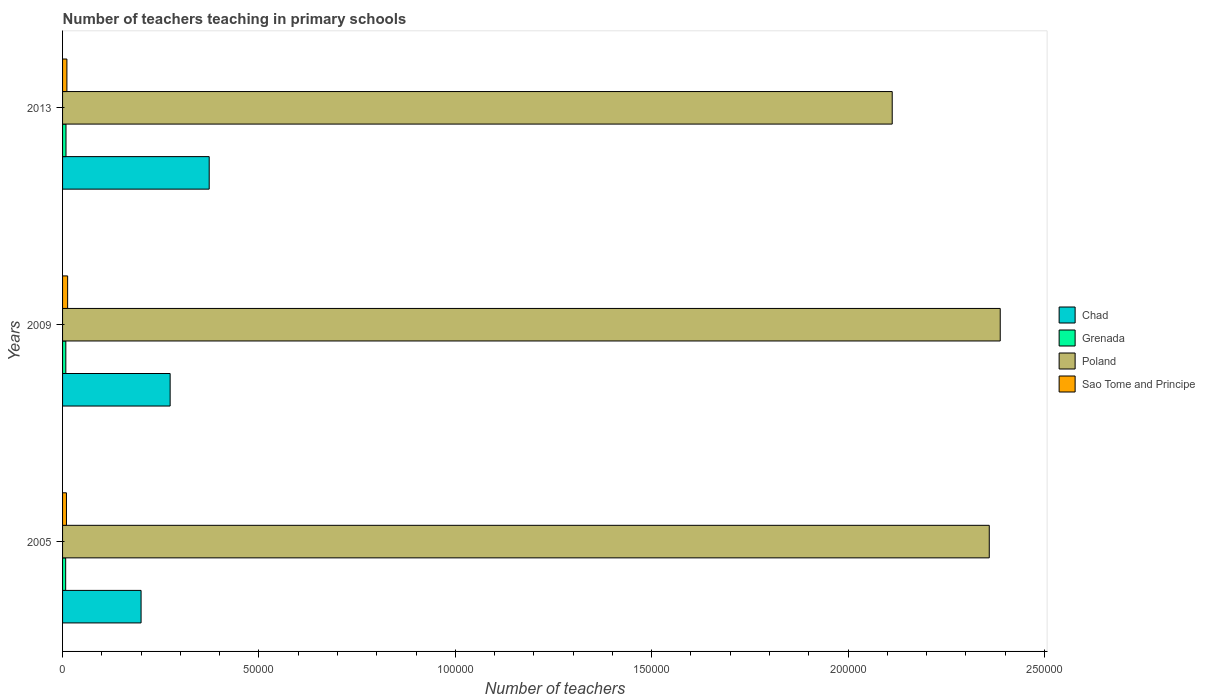How many bars are there on the 2nd tick from the top?
Your answer should be very brief. 4. How many bars are there on the 3rd tick from the bottom?
Make the answer very short. 4. What is the label of the 3rd group of bars from the top?
Your answer should be very brief. 2005. What is the number of teachers teaching in primary schools in Sao Tome and Principe in 2013?
Provide a short and direct response. 1107. Across all years, what is the maximum number of teachers teaching in primary schools in Poland?
Your answer should be compact. 2.39e+05. Across all years, what is the minimum number of teachers teaching in primary schools in Poland?
Offer a terse response. 2.11e+05. In which year was the number of teachers teaching in primary schools in Grenada maximum?
Your response must be concise. 2013. In which year was the number of teachers teaching in primary schools in Chad minimum?
Your response must be concise. 2005. What is the total number of teachers teaching in primary schools in Grenada in the graph?
Offer a very short reply. 2496. What is the difference between the number of teachers teaching in primary schools in Sao Tome and Principe in 2009 and that in 2013?
Keep it short and to the point. 184. What is the difference between the number of teachers teaching in primary schools in Grenada in 2005 and the number of teachers teaching in primary schools in Chad in 2013?
Offer a very short reply. -3.65e+04. What is the average number of teachers teaching in primary schools in Sao Tome and Principe per year?
Your response must be concise. 1129.33. In the year 2005, what is the difference between the number of teachers teaching in primary schools in Sao Tome and Principe and number of teachers teaching in primary schools in Chad?
Give a very brief answer. -1.90e+04. In how many years, is the number of teachers teaching in primary schools in Grenada greater than 10000 ?
Give a very brief answer. 0. What is the ratio of the number of teachers teaching in primary schools in Poland in 2005 to that in 2009?
Offer a very short reply. 0.99. What is the difference between the highest and the lowest number of teachers teaching in primary schools in Sao Tome and Principe?
Offer a terse response. 301. In how many years, is the number of teachers teaching in primary schools in Chad greater than the average number of teachers teaching in primary schools in Chad taken over all years?
Your response must be concise. 1. Is it the case that in every year, the sum of the number of teachers teaching in primary schools in Poland and number of teachers teaching in primary schools in Sao Tome and Principe is greater than the sum of number of teachers teaching in primary schools in Grenada and number of teachers teaching in primary schools in Chad?
Offer a very short reply. Yes. What does the 3rd bar from the top in 2009 represents?
Ensure brevity in your answer.  Grenada. What does the 3rd bar from the bottom in 2013 represents?
Your answer should be compact. Poland. Is it the case that in every year, the sum of the number of teachers teaching in primary schools in Poland and number of teachers teaching in primary schools in Sao Tome and Principe is greater than the number of teachers teaching in primary schools in Chad?
Your answer should be compact. Yes. Are all the bars in the graph horizontal?
Offer a very short reply. Yes. How many years are there in the graph?
Your answer should be compact. 3. What is the difference between two consecutive major ticks on the X-axis?
Make the answer very short. 5.00e+04. Are the values on the major ticks of X-axis written in scientific E-notation?
Give a very brief answer. No. Does the graph contain any zero values?
Keep it short and to the point. No. Where does the legend appear in the graph?
Offer a terse response. Center right. How many legend labels are there?
Offer a very short reply. 4. What is the title of the graph?
Your response must be concise. Number of teachers teaching in primary schools. What is the label or title of the X-axis?
Make the answer very short. Number of teachers. What is the Number of teachers in Chad in 2005?
Keep it short and to the point. 2.00e+04. What is the Number of teachers in Grenada in 2005?
Your response must be concise. 791. What is the Number of teachers in Poland in 2005?
Ensure brevity in your answer.  2.36e+05. What is the Number of teachers of Sao Tome and Principe in 2005?
Make the answer very short. 990. What is the Number of teachers in Chad in 2009?
Provide a succinct answer. 2.74e+04. What is the Number of teachers in Grenada in 2009?
Your answer should be very brief. 830. What is the Number of teachers in Poland in 2009?
Offer a terse response. 2.39e+05. What is the Number of teachers in Sao Tome and Principe in 2009?
Ensure brevity in your answer.  1291. What is the Number of teachers of Chad in 2013?
Your response must be concise. 3.73e+04. What is the Number of teachers of Grenada in 2013?
Keep it short and to the point. 875. What is the Number of teachers in Poland in 2013?
Provide a succinct answer. 2.11e+05. What is the Number of teachers of Sao Tome and Principe in 2013?
Offer a terse response. 1107. Across all years, what is the maximum Number of teachers in Chad?
Ensure brevity in your answer.  3.73e+04. Across all years, what is the maximum Number of teachers of Grenada?
Ensure brevity in your answer.  875. Across all years, what is the maximum Number of teachers of Poland?
Make the answer very short. 2.39e+05. Across all years, what is the maximum Number of teachers of Sao Tome and Principe?
Offer a terse response. 1291. Across all years, what is the minimum Number of teachers of Chad?
Your answer should be compact. 2.00e+04. Across all years, what is the minimum Number of teachers in Grenada?
Give a very brief answer. 791. Across all years, what is the minimum Number of teachers in Poland?
Give a very brief answer. 2.11e+05. Across all years, what is the minimum Number of teachers in Sao Tome and Principe?
Keep it short and to the point. 990. What is the total Number of teachers in Chad in the graph?
Your response must be concise. 8.47e+04. What is the total Number of teachers in Grenada in the graph?
Offer a terse response. 2496. What is the total Number of teachers of Poland in the graph?
Make the answer very short. 6.86e+05. What is the total Number of teachers of Sao Tome and Principe in the graph?
Offer a terse response. 3388. What is the difference between the Number of teachers in Chad in 2005 and that in 2009?
Your answer should be very brief. -7399. What is the difference between the Number of teachers in Grenada in 2005 and that in 2009?
Keep it short and to the point. -39. What is the difference between the Number of teachers of Poland in 2005 and that in 2009?
Your response must be concise. -2791. What is the difference between the Number of teachers of Sao Tome and Principe in 2005 and that in 2009?
Offer a terse response. -301. What is the difference between the Number of teachers of Chad in 2005 and that in 2013?
Your response must be concise. -1.73e+04. What is the difference between the Number of teachers in Grenada in 2005 and that in 2013?
Give a very brief answer. -84. What is the difference between the Number of teachers in Poland in 2005 and that in 2013?
Keep it short and to the point. 2.47e+04. What is the difference between the Number of teachers in Sao Tome and Principe in 2005 and that in 2013?
Provide a succinct answer. -117. What is the difference between the Number of teachers in Chad in 2009 and that in 2013?
Keep it short and to the point. -9948. What is the difference between the Number of teachers of Grenada in 2009 and that in 2013?
Keep it short and to the point. -45. What is the difference between the Number of teachers in Poland in 2009 and that in 2013?
Ensure brevity in your answer.  2.75e+04. What is the difference between the Number of teachers of Sao Tome and Principe in 2009 and that in 2013?
Offer a terse response. 184. What is the difference between the Number of teachers in Chad in 2005 and the Number of teachers in Grenada in 2009?
Offer a very short reply. 1.92e+04. What is the difference between the Number of teachers of Chad in 2005 and the Number of teachers of Poland in 2009?
Make the answer very short. -2.19e+05. What is the difference between the Number of teachers in Chad in 2005 and the Number of teachers in Sao Tome and Principe in 2009?
Give a very brief answer. 1.87e+04. What is the difference between the Number of teachers of Grenada in 2005 and the Number of teachers of Poland in 2009?
Your response must be concise. -2.38e+05. What is the difference between the Number of teachers of Grenada in 2005 and the Number of teachers of Sao Tome and Principe in 2009?
Keep it short and to the point. -500. What is the difference between the Number of teachers in Poland in 2005 and the Number of teachers in Sao Tome and Principe in 2009?
Keep it short and to the point. 2.35e+05. What is the difference between the Number of teachers of Chad in 2005 and the Number of teachers of Grenada in 2013?
Your answer should be compact. 1.91e+04. What is the difference between the Number of teachers of Chad in 2005 and the Number of teachers of Poland in 2013?
Your answer should be compact. -1.91e+05. What is the difference between the Number of teachers of Chad in 2005 and the Number of teachers of Sao Tome and Principe in 2013?
Provide a short and direct response. 1.89e+04. What is the difference between the Number of teachers in Grenada in 2005 and the Number of teachers in Poland in 2013?
Keep it short and to the point. -2.10e+05. What is the difference between the Number of teachers of Grenada in 2005 and the Number of teachers of Sao Tome and Principe in 2013?
Provide a succinct answer. -316. What is the difference between the Number of teachers of Poland in 2005 and the Number of teachers of Sao Tome and Principe in 2013?
Your answer should be compact. 2.35e+05. What is the difference between the Number of teachers in Chad in 2009 and the Number of teachers in Grenada in 2013?
Offer a terse response. 2.65e+04. What is the difference between the Number of teachers of Chad in 2009 and the Number of teachers of Poland in 2013?
Offer a very short reply. -1.84e+05. What is the difference between the Number of teachers of Chad in 2009 and the Number of teachers of Sao Tome and Principe in 2013?
Offer a very short reply. 2.63e+04. What is the difference between the Number of teachers of Grenada in 2009 and the Number of teachers of Poland in 2013?
Offer a very short reply. -2.10e+05. What is the difference between the Number of teachers in Grenada in 2009 and the Number of teachers in Sao Tome and Principe in 2013?
Give a very brief answer. -277. What is the difference between the Number of teachers in Poland in 2009 and the Number of teachers in Sao Tome and Principe in 2013?
Ensure brevity in your answer.  2.38e+05. What is the average Number of teachers in Chad per year?
Give a very brief answer. 2.82e+04. What is the average Number of teachers of Grenada per year?
Give a very brief answer. 832. What is the average Number of teachers in Poland per year?
Your response must be concise. 2.29e+05. What is the average Number of teachers in Sao Tome and Principe per year?
Give a very brief answer. 1129.33. In the year 2005, what is the difference between the Number of teachers of Chad and Number of teachers of Grenada?
Provide a short and direct response. 1.92e+04. In the year 2005, what is the difference between the Number of teachers of Chad and Number of teachers of Poland?
Make the answer very short. -2.16e+05. In the year 2005, what is the difference between the Number of teachers of Chad and Number of teachers of Sao Tome and Principe?
Provide a short and direct response. 1.90e+04. In the year 2005, what is the difference between the Number of teachers in Grenada and Number of teachers in Poland?
Give a very brief answer. -2.35e+05. In the year 2005, what is the difference between the Number of teachers in Grenada and Number of teachers in Sao Tome and Principe?
Make the answer very short. -199. In the year 2005, what is the difference between the Number of teachers of Poland and Number of teachers of Sao Tome and Principe?
Offer a terse response. 2.35e+05. In the year 2009, what is the difference between the Number of teachers of Chad and Number of teachers of Grenada?
Ensure brevity in your answer.  2.66e+04. In the year 2009, what is the difference between the Number of teachers of Chad and Number of teachers of Poland?
Keep it short and to the point. -2.11e+05. In the year 2009, what is the difference between the Number of teachers of Chad and Number of teachers of Sao Tome and Principe?
Ensure brevity in your answer.  2.61e+04. In the year 2009, what is the difference between the Number of teachers in Grenada and Number of teachers in Poland?
Your answer should be very brief. -2.38e+05. In the year 2009, what is the difference between the Number of teachers of Grenada and Number of teachers of Sao Tome and Principe?
Provide a short and direct response. -461. In the year 2009, what is the difference between the Number of teachers of Poland and Number of teachers of Sao Tome and Principe?
Keep it short and to the point. 2.37e+05. In the year 2013, what is the difference between the Number of teachers in Chad and Number of teachers in Grenada?
Ensure brevity in your answer.  3.65e+04. In the year 2013, what is the difference between the Number of teachers in Chad and Number of teachers in Poland?
Give a very brief answer. -1.74e+05. In the year 2013, what is the difference between the Number of teachers of Chad and Number of teachers of Sao Tome and Principe?
Your answer should be very brief. 3.62e+04. In the year 2013, what is the difference between the Number of teachers in Grenada and Number of teachers in Poland?
Give a very brief answer. -2.10e+05. In the year 2013, what is the difference between the Number of teachers in Grenada and Number of teachers in Sao Tome and Principe?
Give a very brief answer. -232. In the year 2013, what is the difference between the Number of teachers of Poland and Number of teachers of Sao Tome and Principe?
Provide a succinct answer. 2.10e+05. What is the ratio of the Number of teachers in Chad in 2005 to that in 2009?
Keep it short and to the point. 0.73. What is the ratio of the Number of teachers of Grenada in 2005 to that in 2009?
Keep it short and to the point. 0.95. What is the ratio of the Number of teachers in Poland in 2005 to that in 2009?
Offer a very short reply. 0.99. What is the ratio of the Number of teachers of Sao Tome and Principe in 2005 to that in 2009?
Give a very brief answer. 0.77. What is the ratio of the Number of teachers in Chad in 2005 to that in 2013?
Provide a succinct answer. 0.54. What is the ratio of the Number of teachers of Grenada in 2005 to that in 2013?
Provide a short and direct response. 0.9. What is the ratio of the Number of teachers in Poland in 2005 to that in 2013?
Give a very brief answer. 1.12. What is the ratio of the Number of teachers of Sao Tome and Principe in 2005 to that in 2013?
Provide a short and direct response. 0.89. What is the ratio of the Number of teachers in Chad in 2009 to that in 2013?
Keep it short and to the point. 0.73. What is the ratio of the Number of teachers of Grenada in 2009 to that in 2013?
Make the answer very short. 0.95. What is the ratio of the Number of teachers of Poland in 2009 to that in 2013?
Your answer should be very brief. 1.13. What is the ratio of the Number of teachers of Sao Tome and Principe in 2009 to that in 2013?
Provide a short and direct response. 1.17. What is the difference between the highest and the second highest Number of teachers in Chad?
Your answer should be compact. 9948. What is the difference between the highest and the second highest Number of teachers of Poland?
Provide a succinct answer. 2791. What is the difference between the highest and the second highest Number of teachers in Sao Tome and Principe?
Provide a short and direct response. 184. What is the difference between the highest and the lowest Number of teachers in Chad?
Your answer should be compact. 1.73e+04. What is the difference between the highest and the lowest Number of teachers in Grenada?
Keep it short and to the point. 84. What is the difference between the highest and the lowest Number of teachers of Poland?
Your answer should be very brief. 2.75e+04. What is the difference between the highest and the lowest Number of teachers of Sao Tome and Principe?
Your answer should be very brief. 301. 